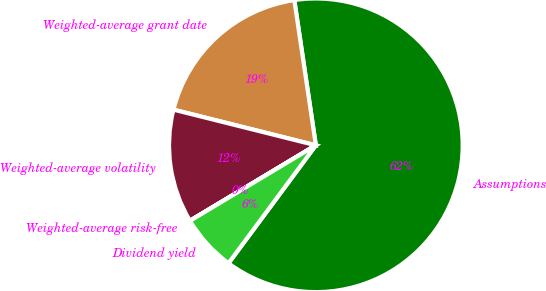Convert chart. <chart><loc_0><loc_0><loc_500><loc_500><pie_chart><fcel>Assumptions<fcel>Weighted-average grant date<fcel>Weighted-average volatility<fcel>Weighted-average risk-free<fcel>Dividend yield<nl><fcel>62.49%<fcel>18.75%<fcel>12.5%<fcel>0.01%<fcel>6.25%<nl></chart> 